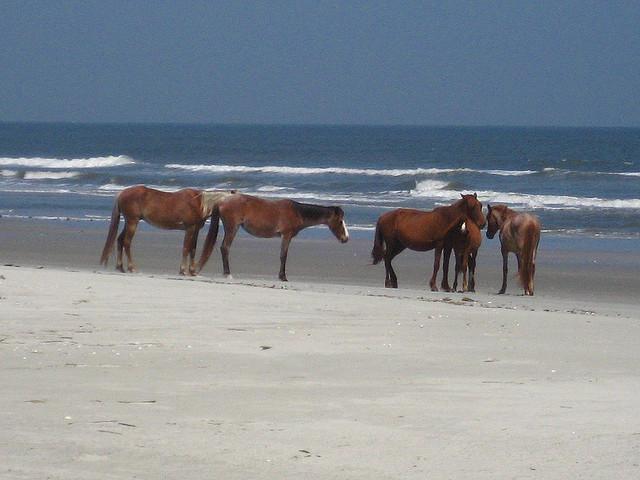How many horses are in the picture?
Give a very brief answer. 4. How many train cars are there?
Give a very brief answer. 0. 